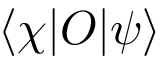Convert formula to latex. <formula><loc_0><loc_0><loc_500><loc_500>\langle \chi | O | \psi \rangle</formula> 